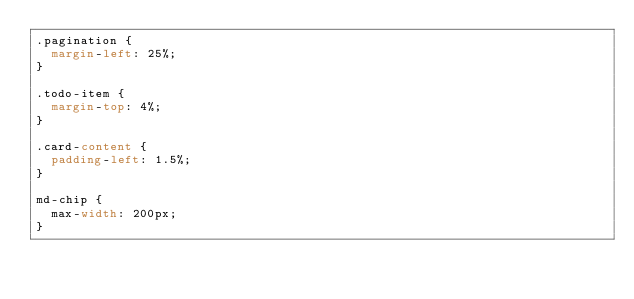<code> <loc_0><loc_0><loc_500><loc_500><_CSS_>.pagination {
  margin-left: 25%;
}

.todo-item {
  margin-top: 4%;
}

.card-content {
  padding-left: 1.5%;
}

md-chip {
  max-width: 200px;
}
</code> 